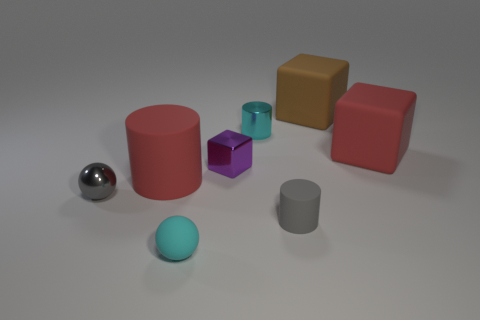What number of things are tiny matte things left of the tiny purple shiny cube or rubber objects behind the shiny ball?
Offer a terse response. 4. Are there fewer blocks than purple cubes?
Your answer should be very brief. No. Is the size of the cyan ball the same as the red object left of the brown thing?
Your response must be concise. No. How many shiny objects are either blue balls or big brown things?
Offer a very short reply. 0. Are there more red matte cylinders than big gray rubber things?
Your answer should be compact. Yes. The shiny object that is the same color as the small matte cylinder is what size?
Provide a short and direct response. Small. The small gray metallic object behind the cyan thing in front of the large red matte cylinder is what shape?
Your response must be concise. Sphere. Is there a metallic thing on the right side of the large matte thing that is left of the big matte cube to the left of the red cube?
Offer a very short reply. Yes. What color is the shiny ball that is the same size as the metallic block?
Your answer should be compact. Gray. The thing that is in front of the tiny gray metal sphere and on the right side of the shiny cylinder has what shape?
Your answer should be very brief. Cylinder. 